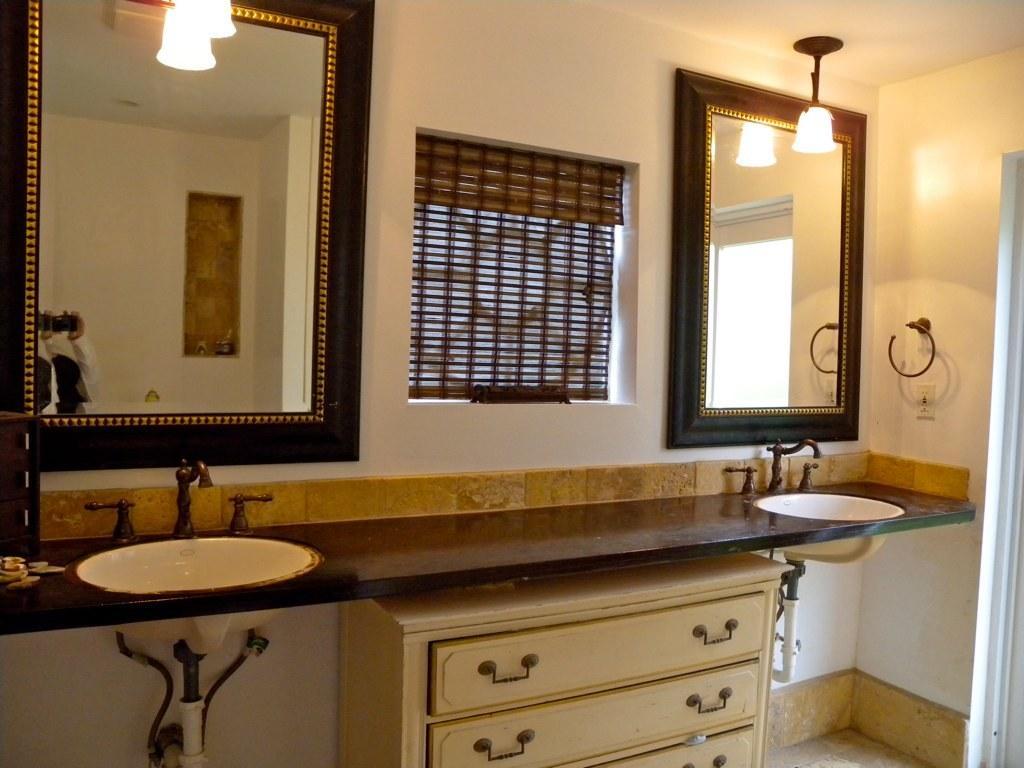Describe this image in one or two sentences. In this image we can see there are two sinks on either side of the image. In the middle there are drawers. At the top there are two mirrors on either side. In front of them there are lamps. In the middle it looks a window. On the right side there is a handle which is fixed to the wall. 